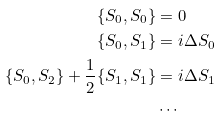<formula> <loc_0><loc_0><loc_500><loc_500>\{ S _ { 0 } , S _ { 0 } \} & = 0 \\ \{ S _ { 0 } , S _ { 1 } \} & = i \Delta S _ { 0 } \\ \{ S _ { 0 } , S _ { 2 } \} + \frac { 1 } { 2 } \{ S _ { 1 } , S _ { 1 } \} & = i \Delta S _ { 1 } \\ & \cdots</formula> 